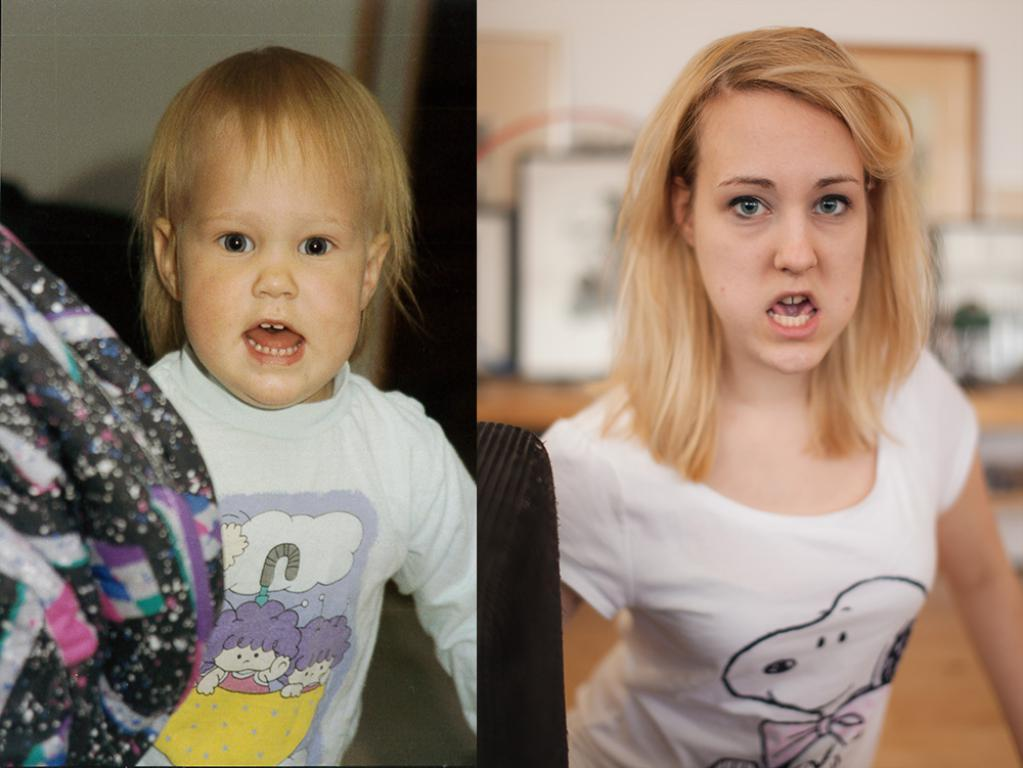What is the composition of the image? The image is a collage of two different pictures. What can be seen in the first picture? In the first picture, there is a kid wearing clothes. What can be seen in the second picture? In the second picture, there is a lady wearing clothes. What type of alarm is going off in the image? There is no alarm present in the image; it is a collage of two pictures featuring a kid and a lady wearing clothes. 